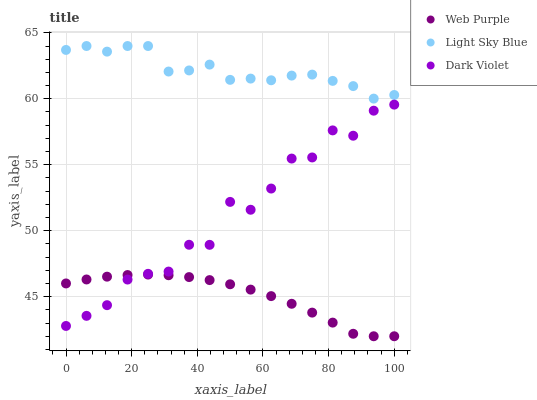Does Web Purple have the minimum area under the curve?
Answer yes or no. Yes. Does Light Sky Blue have the maximum area under the curve?
Answer yes or no. Yes. Does Dark Violet have the minimum area under the curve?
Answer yes or no. No. Does Dark Violet have the maximum area under the curve?
Answer yes or no. No. Is Web Purple the smoothest?
Answer yes or no. Yes. Is Dark Violet the roughest?
Answer yes or no. Yes. Is Light Sky Blue the smoothest?
Answer yes or no. No. Is Light Sky Blue the roughest?
Answer yes or no. No. Does Web Purple have the lowest value?
Answer yes or no. Yes. Does Dark Violet have the lowest value?
Answer yes or no. No. Does Light Sky Blue have the highest value?
Answer yes or no. Yes. Does Dark Violet have the highest value?
Answer yes or no. No. Is Dark Violet less than Light Sky Blue?
Answer yes or no. Yes. Is Light Sky Blue greater than Web Purple?
Answer yes or no. Yes. Does Web Purple intersect Dark Violet?
Answer yes or no. Yes. Is Web Purple less than Dark Violet?
Answer yes or no. No. Is Web Purple greater than Dark Violet?
Answer yes or no. No. Does Dark Violet intersect Light Sky Blue?
Answer yes or no. No. 